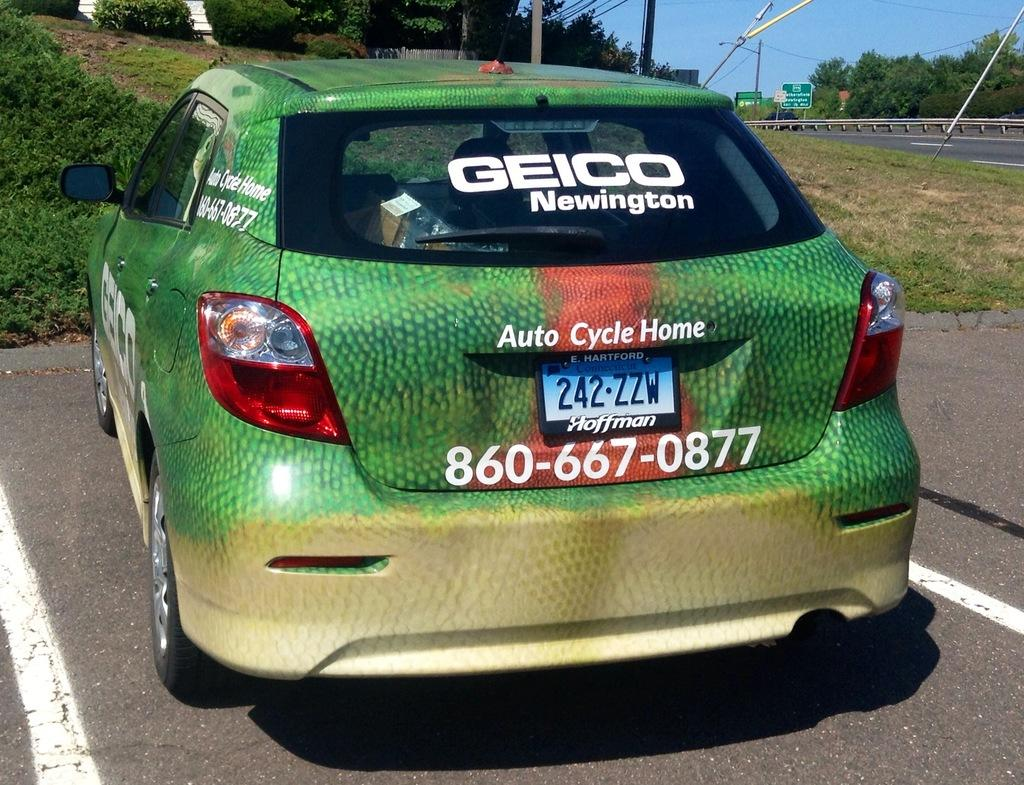What is the main subject of the image? There is a car in the image. What can be seen on the right side of the image? There is a road with sign boards and poles on the right side of the image. What is visible in the background of the image? There are trees, plants, and the sky visible in the background of the image. What type of cloth is draped over the car in the image? There is no cloth draped over the car in the image. Can you describe the garden in the background of the image? There is no garden present in the image; only trees, plants, and the sky are visible in the background. 